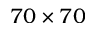<formula> <loc_0><loc_0><loc_500><loc_500>7 0 \times 7 0</formula> 